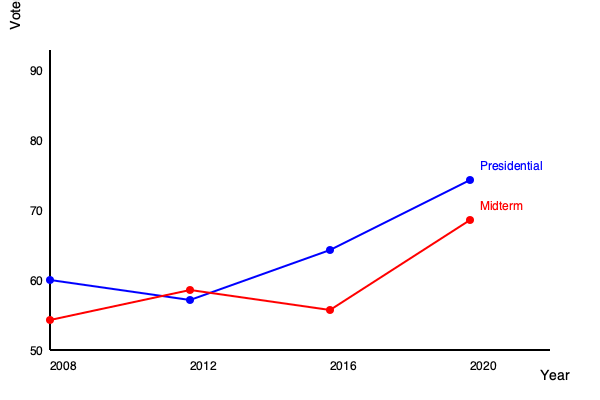Based on the line graph showing voter turnout trends in Wisconsin from 2008 to 2020, what can be inferred about the difference in voter engagement between presidential and midterm elections, and how might this impact political campaign strategies in the state? To analyze this graph and answer the question, let's break it down step-by-step:

1. Identify the trends:
   - The blue line represents presidential election turnout.
   - The red line represents midterm election turnout.

2. Compare presidential vs. midterm elections:
   - Presidential elections consistently show higher turnout than midterm elections.
   - The gap between presidential and midterm turnout varies across years.

3. Analyze the presidential election trend (blue line):
   - 2008: Approximately 62% turnout
   - 2012: Slight increase to about 64%
   - 2016: Significant increase to around 70%
   - 2020: Major increase to approximately 75%

4. Analyze the midterm election trend (red line):
   - 2010: About 56% turnout
   - 2014: Slight increase to around 58%
   - 2018: Significant increase to about 66%

5. Observe the narrowing gap:
   - The difference between presidential and midterm turnout has decreased over time.
   - 2010 vs. 2008: ~6 percentage point difference
   - 2018 vs. 2016: ~4 percentage point difference

6. Consider implications for political campaigns:
   - Increasing overall engagement: Both types of elections show an upward trend in turnout.
   - Narrowing enthusiasm gap: Midterm elections are gaining importance among voters.
   - Resource allocation: Campaigns may need to invest more heavily in midterm elections.
   - Messaging strategies: Emphasize the importance of midterm elections to maintain momentum.
   - Voter outreach: Develop strategies to engage voters consistently across all election types.

7. Potential factors influencing these trends:
   - Increased political polarization
   - Enhanced get-out-the-vote efforts
   - Growing awareness of the importance of state and local elections
   - Improved voter access and registration methods
Answer: Voter engagement in Wisconsin has increased for both presidential and midterm elections, with the gap between them narrowing. This trend suggests campaigns should allocate more resources to midterms and emphasize their importance to maintain voter enthusiasm across all election types. 